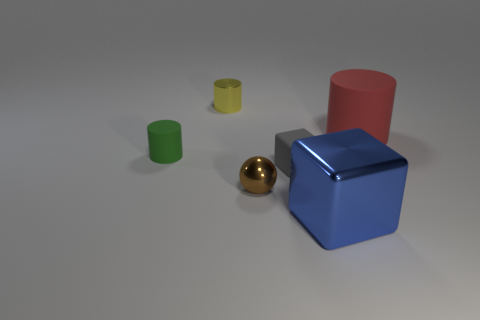Is the number of yellow cylinders on the right side of the small yellow cylinder the same as the number of big things? no 